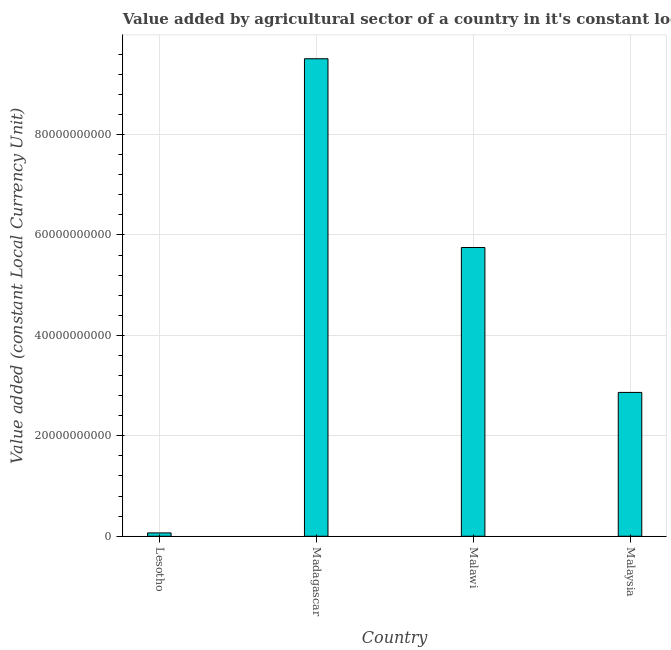Does the graph contain any zero values?
Give a very brief answer. No. What is the title of the graph?
Your answer should be very brief. Value added by agricultural sector of a country in it's constant local currency unit. What is the label or title of the X-axis?
Give a very brief answer. Country. What is the label or title of the Y-axis?
Keep it short and to the point. Value added (constant Local Currency Unit). What is the value added by agriculture sector in Lesotho?
Make the answer very short. 6.65e+08. Across all countries, what is the maximum value added by agriculture sector?
Offer a terse response. 9.51e+1. Across all countries, what is the minimum value added by agriculture sector?
Keep it short and to the point. 6.65e+08. In which country was the value added by agriculture sector maximum?
Your response must be concise. Madagascar. In which country was the value added by agriculture sector minimum?
Offer a very short reply. Lesotho. What is the sum of the value added by agriculture sector?
Provide a succinct answer. 1.82e+11. What is the difference between the value added by agriculture sector in Lesotho and Malawi?
Provide a short and direct response. -5.68e+1. What is the average value added by agriculture sector per country?
Offer a terse response. 4.55e+1. What is the median value added by agriculture sector?
Offer a very short reply. 4.31e+1. In how many countries, is the value added by agriculture sector greater than 76000000000 LCU?
Offer a terse response. 1. What is the ratio of the value added by agriculture sector in Lesotho to that in Malawi?
Provide a succinct answer. 0.01. Is the value added by agriculture sector in Madagascar less than that in Malawi?
Give a very brief answer. No. Is the difference between the value added by agriculture sector in Lesotho and Malaysia greater than the difference between any two countries?
Give a very brief answer. No. What is the difference between the highest and the second highest value added by agriculture sector?
Your response must be concise. 3.76e+1. What is the difference between the highest and the lowest value added by agriculture sector?
Provide a short and direct response. 9.44e+1. In how many countries, is the value added by agriculture sector greater than the average value added by agriculture sector taken over all countries?
Your answer should be compact. 2. How many bars are there?
Offer a very short reply. 4. How many countries are there in the graph?
Ensure brevity in your answer.  4. What is the difference between two consecutive major ticks on the Y-axis?
Provide a succinct answer. 2.00e+1. What is the Value added (constant Local Currency Unit) in Lesotho?
Your response must be concise. 6.65e+08. What is the Value added (constant Local Currency Unit) in Madagascar?
Keep it short and to the point. 9.51e+1. What is the Value added (constant Local Currency Unit) in Malawi?
Ensure brevity in your answer.  5.75e+1. What is the Value added (constant Local Currency Unit) in Malaysia?
Provide a succinct answer. 2.86e+1. What is the difference between the Value added (constant Local Currency Unit) in Lesotho and Madagascar?
Give a very brief answer. -9.44e+1. What is the difference between the Value added (constant Local Currency Unit) in Lesotho and Malawi?
Provide a succinct answer. -5.68e+1. What is the difference between the Value added (constant Local Currency Unit) in Lesotho and Malaysia?
Offer a terse response. -2.80e+1. What is the difference between the Value added (constant Local Currency Unit) in Madagascar and Malawi?
Give a very brief answer. 3.76e+1. What is the difference between the Value added (constant Local Currency Unit) in Madagascar and Malaysia?
Provide a short and direct response. 6.65e+1. What is the difference between the Value added (constant Local Currency Unit) in Malawi and Malaysia?
Your answer should be very brief. 2.89e+1. What is the ratio of the Value added (constant Local Currency Unit) in Lesotho to that in Madagascar?
Give a very brief answer. 0.01. What is the ratio of the Value added (constant Local Currency Unit) in Lesotho to that in Malawi?
Offer a terse response. 0.01. What is the ratio of the Value added (constant Local Currency Unit) in Lesotho to that in Malaysia?
Your answer should be compact. 0.02. What is the ratio of the Value added (constant Local Currency Unit) in Madagascar to that in Malawi?
Offer a terse response. 1.65. What is the ratio of the Value added (constant Local Currency Unit) in Madagascar to that in Malaysia?
Provide a succinct answer. 3.32. What is the ratio of the Value added (constant Local Currency Unit) in Malawi to that in Malaysia?
Offer a very short reply. 2.01. 